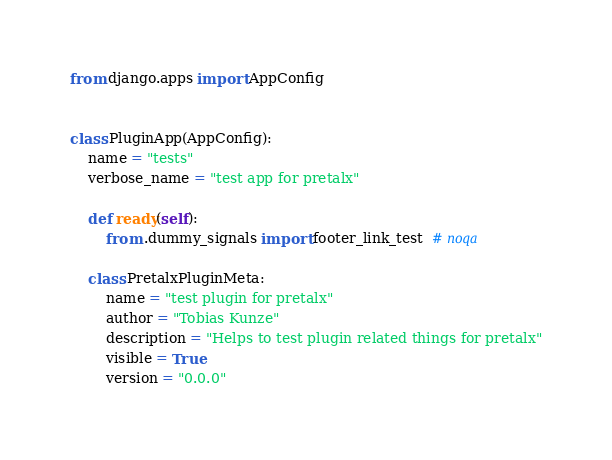<code> <loc_0><loc_0><loc_500><loc_500><_Python_>from django.apps import AppConfig


class PluginApp(AppConfig):
    name = "tests"
    verbose_name = "test app for pretalx"

    def ready(self):
        from .dummy_signals import footer_link_test  # noqa

    class PretalxPluginMeta:
        name = "test plugin for pretalx"
        author = "Tobias Kunze"
        description = "Helps to test plugin related things for pretalx"
        visible = True
        version = "0.0.0"
</code> 